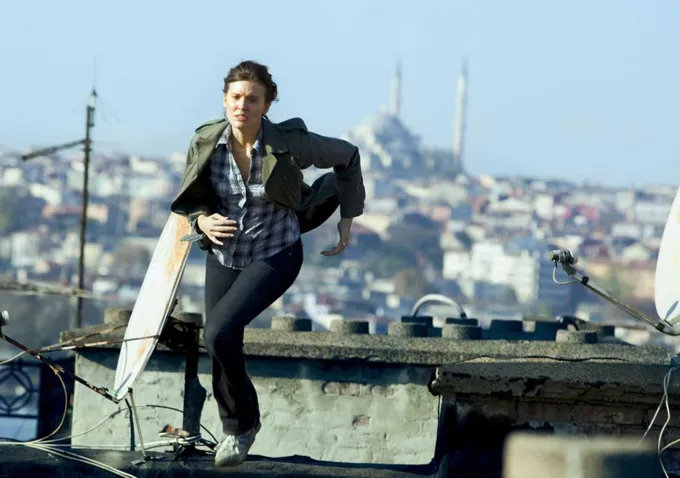Describe the architecture seen in the background. The background features a variety of buildings indicative of a dense urban environment. There are low-rise structures with flat roofs, characteristic of many cityscapes, and the distant outline of a hill with what appears to be a large, significant building or complex with multiple spires or towers, maybe a historic or religious site. The architectural styles suggest a mix of modern and possibly historic influences. Can you tell anything about the climate of the area from the image? The clear blue skies and the attire of the person, which is suitable for milder weather, suggest the climate is temperate at the time of the image. There are no signs of rain or snow, and the overall brightness of the scene implies a fair weather pattern. 